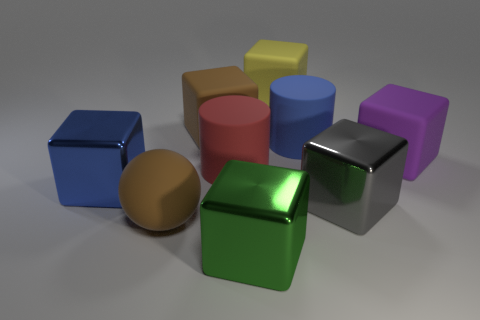What might be the sizes of these objects relative to each other? While it’s challenging to determine the exact sizes without a reference, the objects appear to vary in size. The larger shapes, such as the cylinders and the cube, dominate the space, while the smaller shapes, like the smaller cubes and spheres, add diversity to the arrangement. 